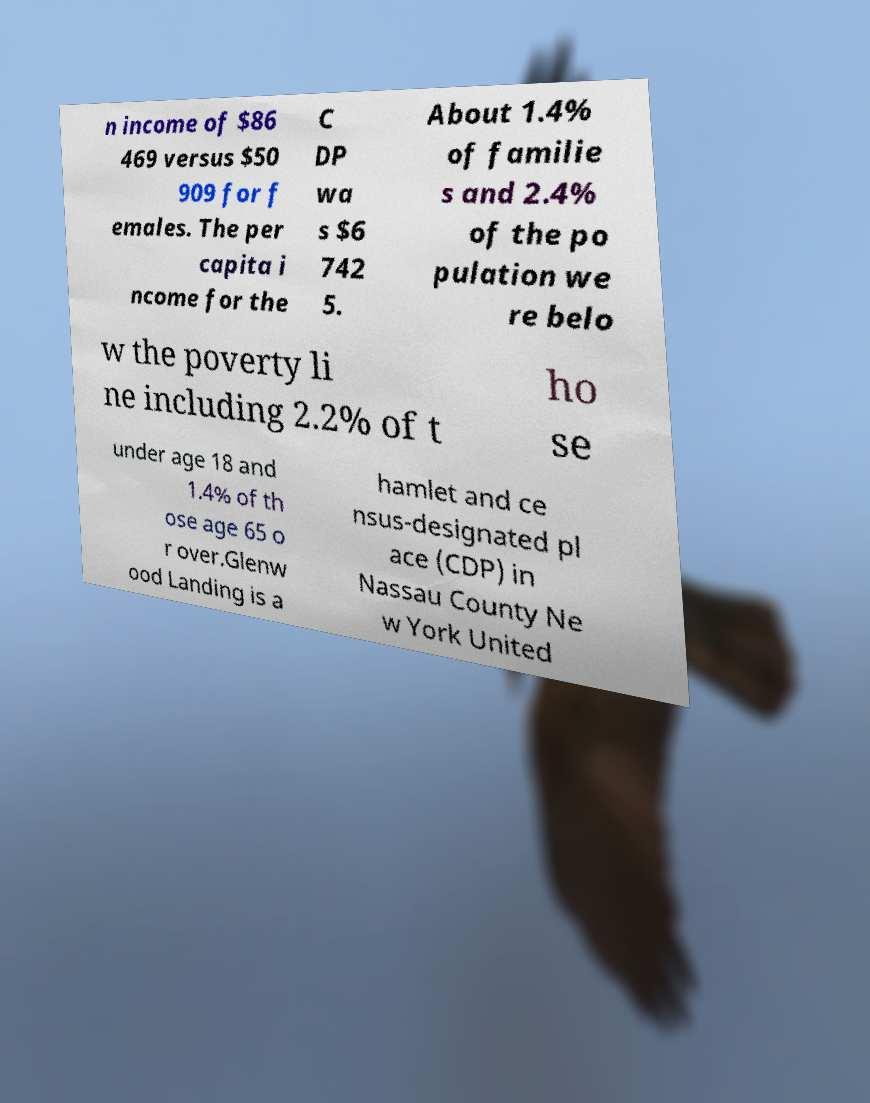Could you assist in decoding the text presented in this image and type it out clearly? n income of $86 469 versus $50 909 for f emales. The per capita i ncome for the C DP wa s $6 742 5. About 1.4% of familie s and 2.4% of the po pulation we re belo w the poverty li ne including 2.2% of t ho se under age 18 and 1.4% of th ose age 65 o r over.Glenw ood Landing is a hamlet and ce nsus-designated pl ace (CDP) in Nassau County Ne w York United 